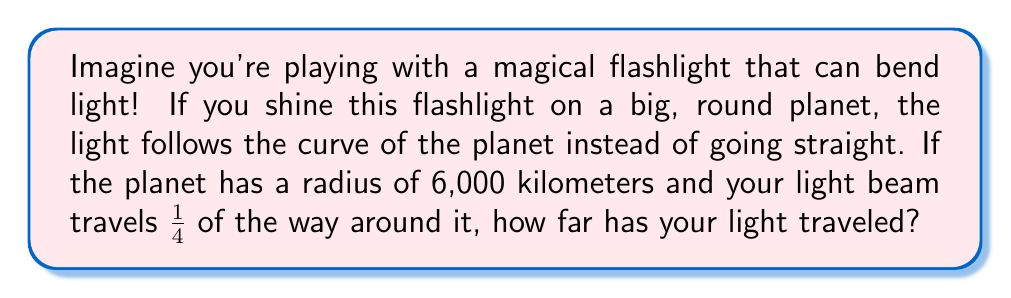Show me your answer to this math problem. Let's break this down step-by-step:

1. First, we need to understand that the light is traveling along the surface of a sphere (the planet). This means it's following a circular path.

2. We know that the full circumference of a circle is given by the formula:
   $$C = 2\pi r$$
   Where $C$ is the circumference and $r$ is the radius.

3. We're told that the radius of the planet is 6,000 kilometers. Let's plug this into our formula:
   $$C = 2\pi \cdot 6,000$$

4. If we calculate this, we get:
   $$C \approx 37,699 \text{ kilometers}$$

5. But remember, our light beam only travels 1/4 of the way around the planet. So we need to divide this result by 4:
   $$\text{Distance traveled} = \frac{37,699}{4} \approx 9,425 \text{ kilometers}$$

6. We can also express this more precisely using fractions and $\pi$:
   $$\text{Distance traveled} = \frac{1}{4} \cdot 2\pi r = \frac{\pi r}{2} = \frac{\pi \cdot 6,000}{2} = 3,000\pi \text{ kilometers}$$

So, your magical light beam has traveled approximately 9,425 kilometers, or more precisely, $3,000\pi$ kilometers!
Answer: $3,000\pi$ kilometers 